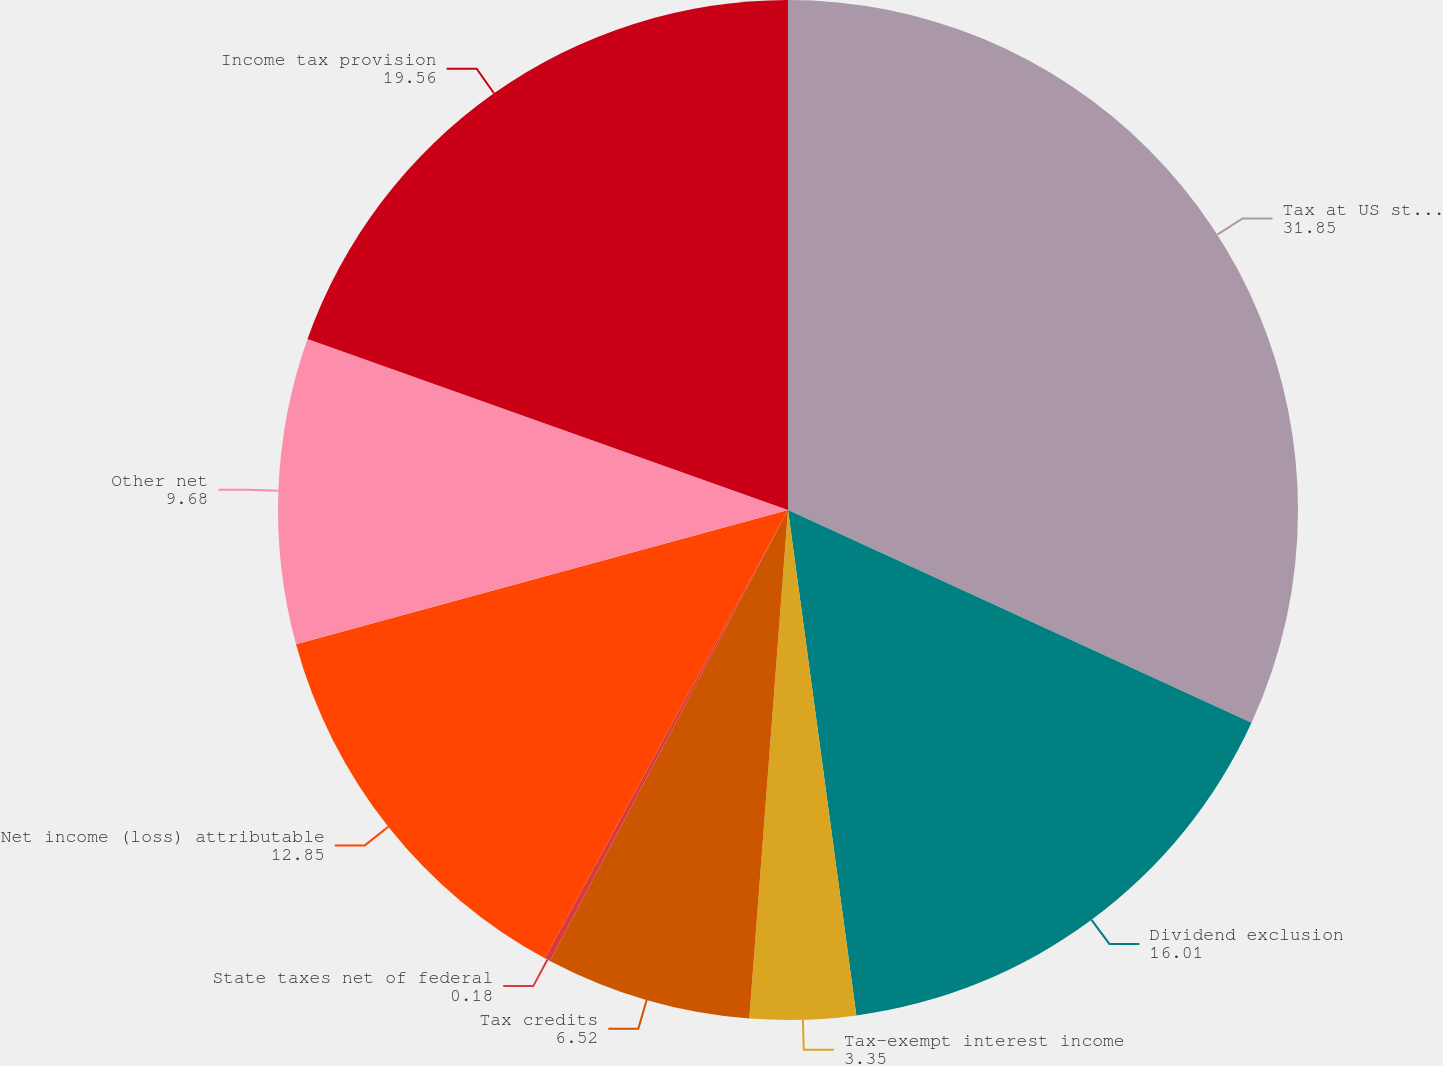<chart> <loc_0><loc_0><loc_500><loc_500><pie_chart><fcel>Tax at US statutory rate<fcel>Dividend exclusion<fcel>Tax-exempt interest income<fcel>Tax credits<fcel>State taxes net of federal<fcel>Net income (loss) attributable<fcel>Other net<fcel>Income tax provision<nl><fcel>31.85%<fcel>16.01%<fcel>3.35%<fcel>6.52%<fcel>0.18%<fcel>12.85%<fcel>9.68%<fcel>19.56%<nl></chart> 